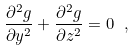<formula> <loc_0><loc_0><loc_500><loc_500>\frac { \partial ^ { 2 } g } { \partial y ^ { 2 } } + \frac { \partial ^ { 2 } g } { \partial z ^ { 2 } } = 0 \ ,</formula> 